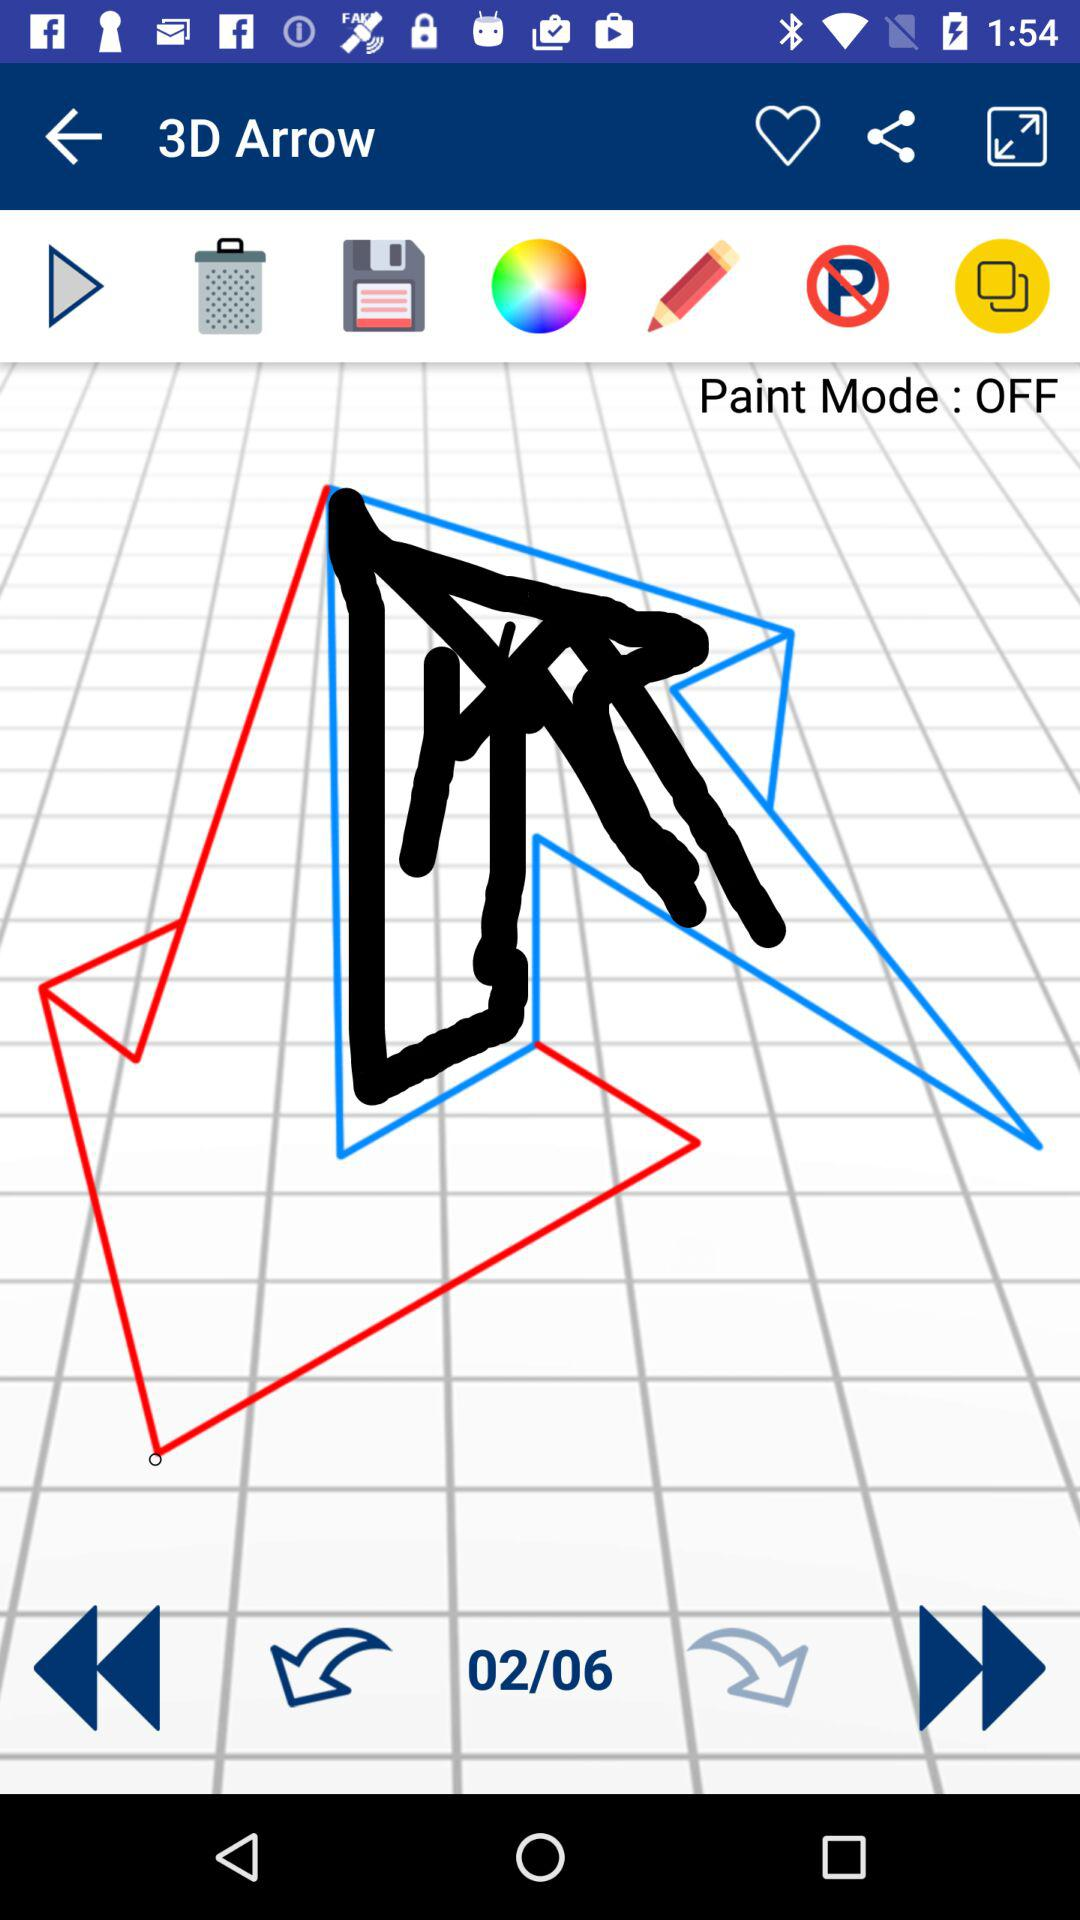How many steps in total are there? There are 6 steps in total. 